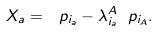Convert formula to latex. <formula><loc_0><loc_0><loc_500><loc_500>X _ { a } = \ p _ { i _ { a } } - \lambda ^ { A } _ { i _ { a } } \ p _ { i _ { A } } .</formula> 